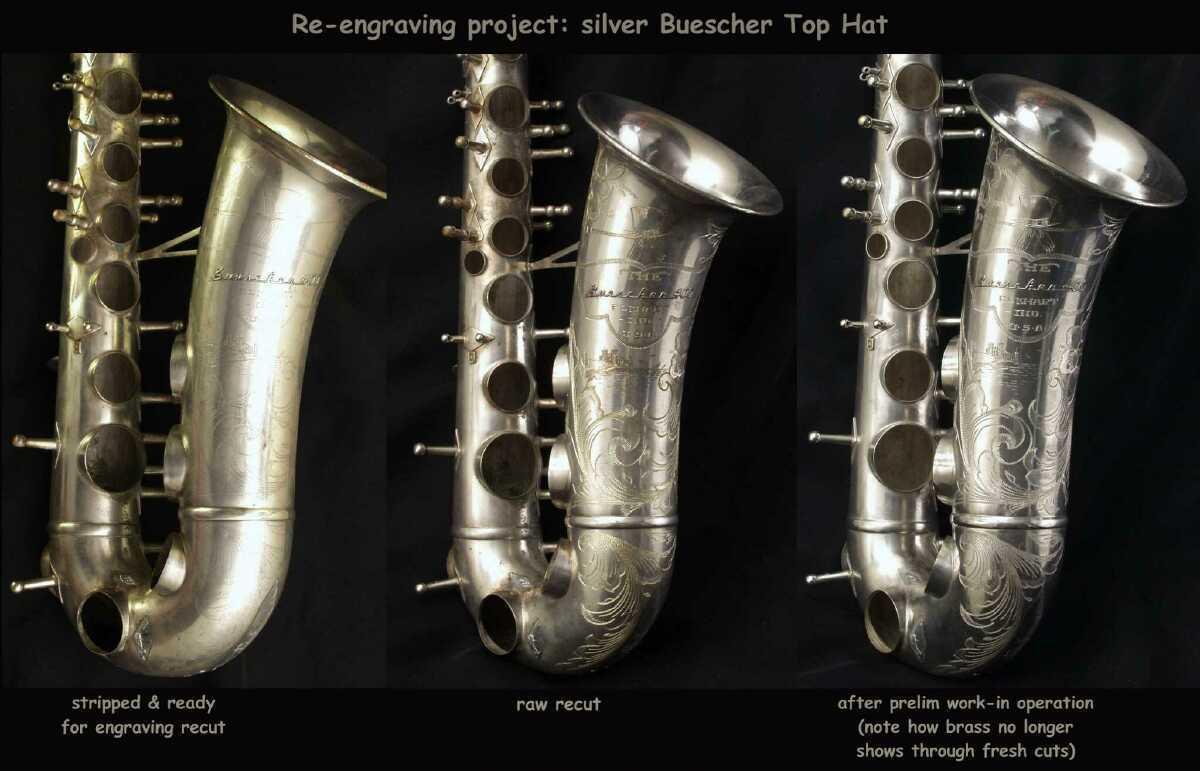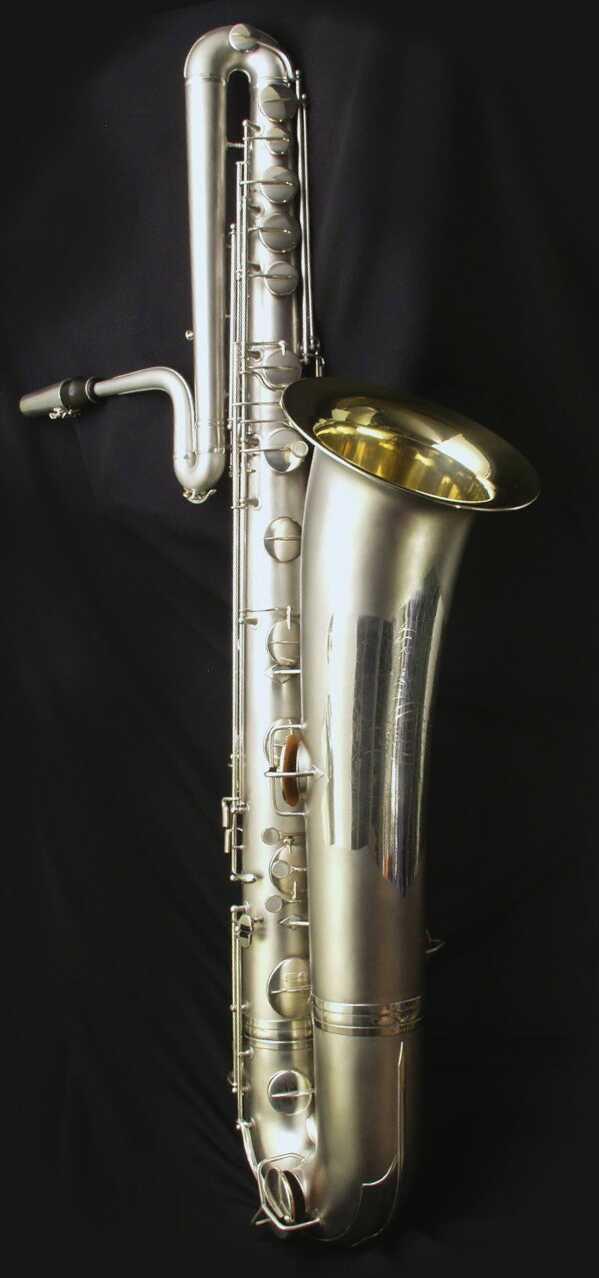The first image is the image on the left, the second image is the image on the right. Considering the images on both sides, is "The right image shows a gold-colored saxophone displayed at an angle on off-white fabric, with its mouthpiece separated and laying near it." valid? Answer yes or no. No. The first image is the image on the left, the second image is the image on the right. Assess this claim about the two images: "A saxophone with the mouth piece removed is laying on a wrinkled tan colored cloth.". Correct or not? Answer yes or no. No. 